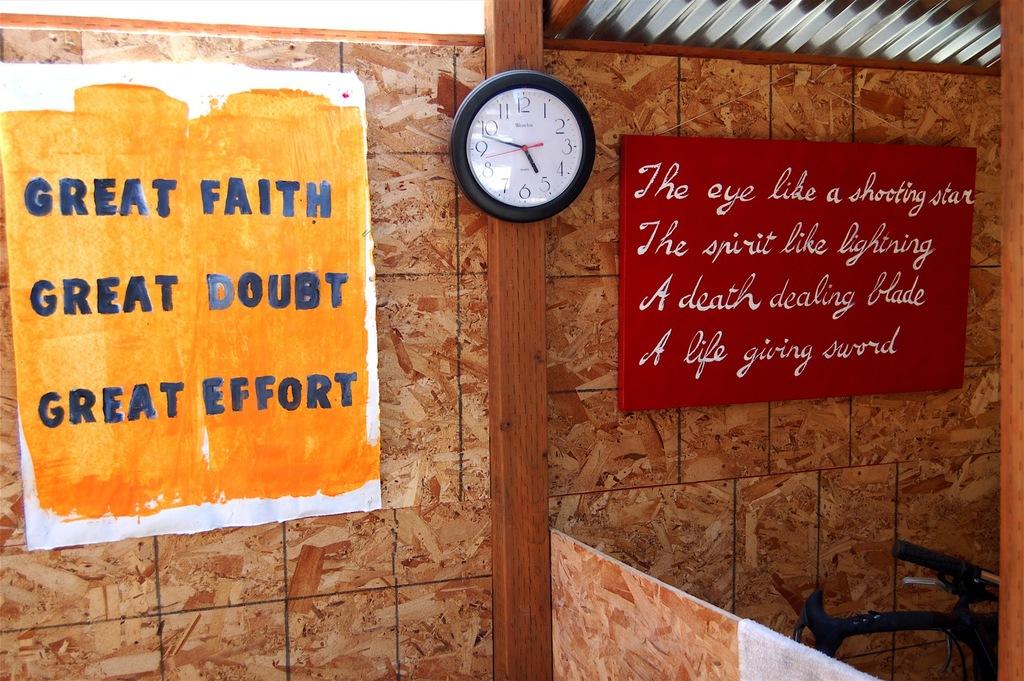What time is displayed on the clock?
Keep it short and to the point. 5:49. What kind of sword is in the quote?
Make the answer very short. Life giving. 